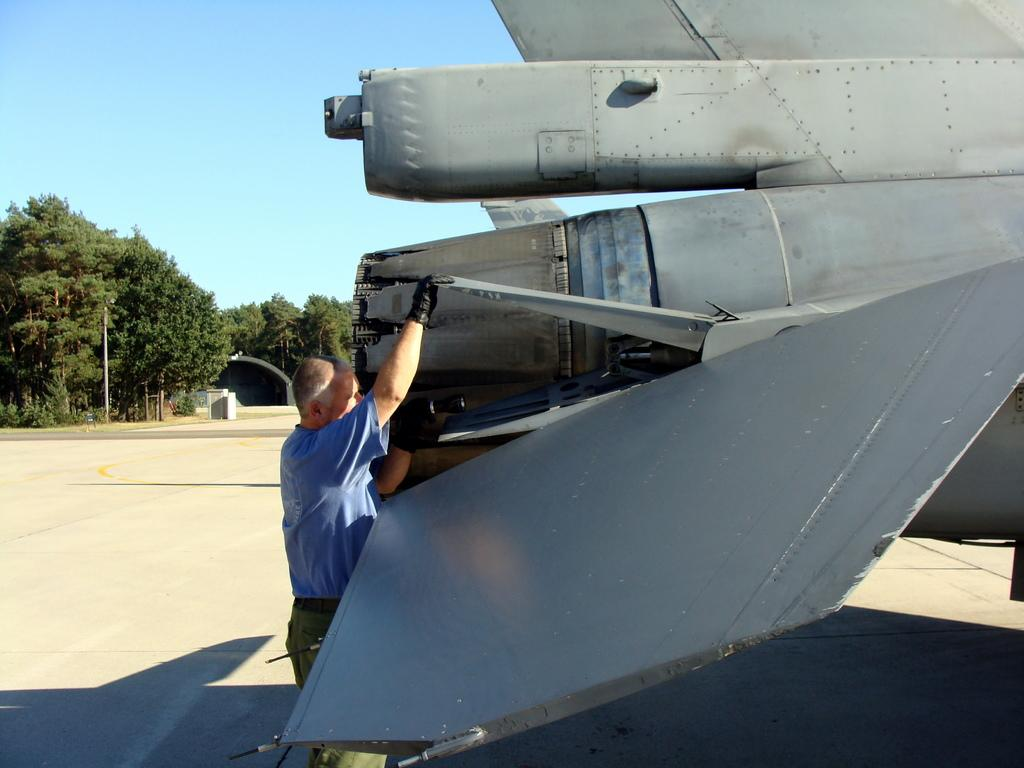What is the main subject of the image? The main subject of the image is a plane. Who is operating the plane? A man is operating the plane. What is the color of the plane? The plane is grey in color. What can be seen in the background of the image? There is a shadow of the plane, trees, and the sky visible in the background. What type of metal is the glove made of in the image? There is no glove present in the image. What tasks is the maid performing in the image? There is no maid present in the image. 